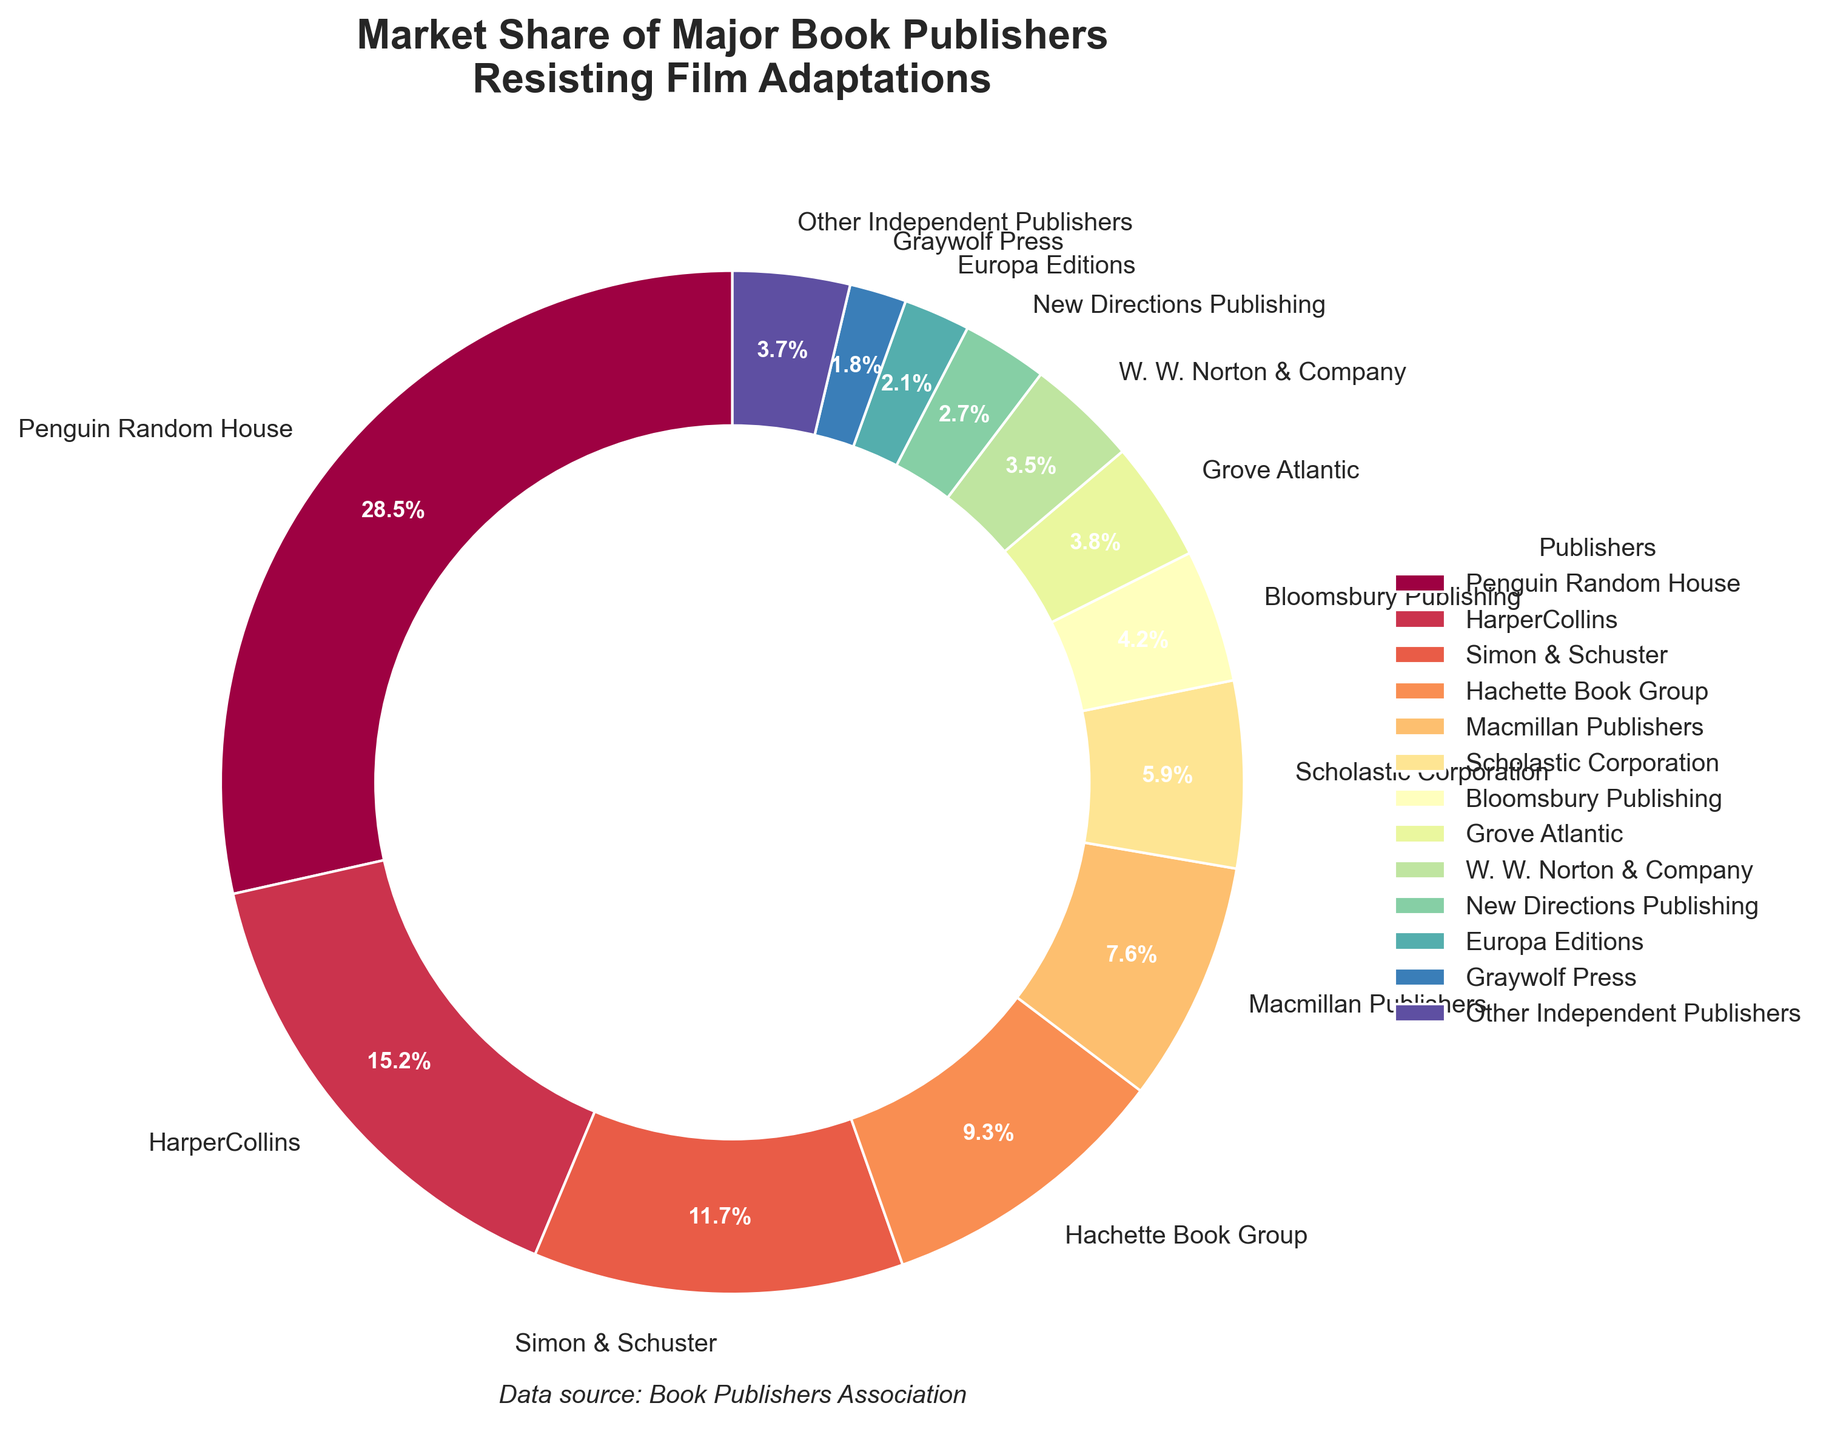What is the market share of the largest publisher resisting film adaptations? Penguin Random House has the largest market share. According to the figure, its market share is 28.5%.
Answer: 28.5% Which publisher has a higher market share, HarperCollins or Simon & Schuster? By referencing the figure, HarperCollins holds 15.2% of the market share while Simon & Schuster holds 11.7%. Therefore, HarperCollins has a higher market share.
Answer: HarperCollins What is the combined market share of Macmillan Publishers and Bloomsbury Publishing? Macmillan Publishers has a market share of 7.6% and Bloomsbury Publishing has 4.2%. Adding these together gives a combined market share of 7.6% + 4.2% = 11.8%.
Answer: 11.8% How much larger is Penguin Random House's market share compared to Graywolf Press? Penguin Random House's market share is 28.5%, whereas Graywolf Press's market share is 1.8%. The difference is 28.5% - 1.8% = 26.7%.
Answer: 26.7% Which publishers have a market share less than 5%? According to the figure, the publishers with a market share less than 5% are Bloomsbury Publishing (4.2%), Grove Atlantic (3.8%), W. W. Norton & Company (3.5%), New Directions Publishing (2.7%), Europa Editions (2.1%), and Graywolf Press (1.8%).
Answer: Bloomsbury Publishing, Grove Atlantic, W. W. Norton & Company, New Directions Publishing, Europa Editions, Graywolf Press By looking at the colors, which publisher is represented by the slice next to New Directions Publishing? The adjacent slice is represented by a distinct color and labeled appropriately. New Directions Publishing is right next to Europa Editions (2.1%).
Answer: Europa Editions If another publisher with a market share of 5.0% were to resist film adaptations, what would be the new total market share for "Other Independent Publishers"? If the new publisher joined the "Other Independent Publishers", the combined share would be their current share (3.7%) plus the new share (5.0%), giving 3.7% + 5.0% = 8.7%.
Answer: 8.7% Which section of the pie chart is closest to the center in radius, Scholastic Corporation or Simon & Schuster? Observing the pie chart, all sections are equidistant from the center in terms of inner radius due to the design of the doughnut chart. Therefore, both Scholastic Corporation and Simon & Schuster are equidistant from the center.
Answer: Equidistant 